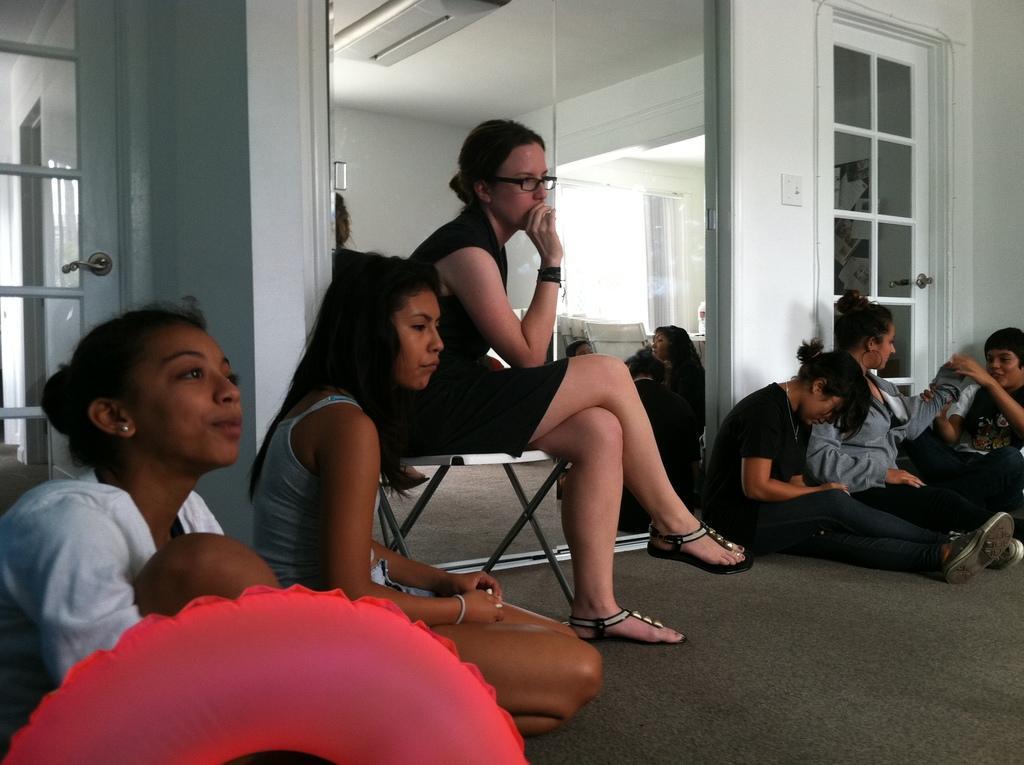Could you give a brief overview of what you see in this image? In this picture we can see a woman sitting on the chair. She has spectacles. Here we can see some persons are sitting on the floor. On the background there is a wall and this is door. 